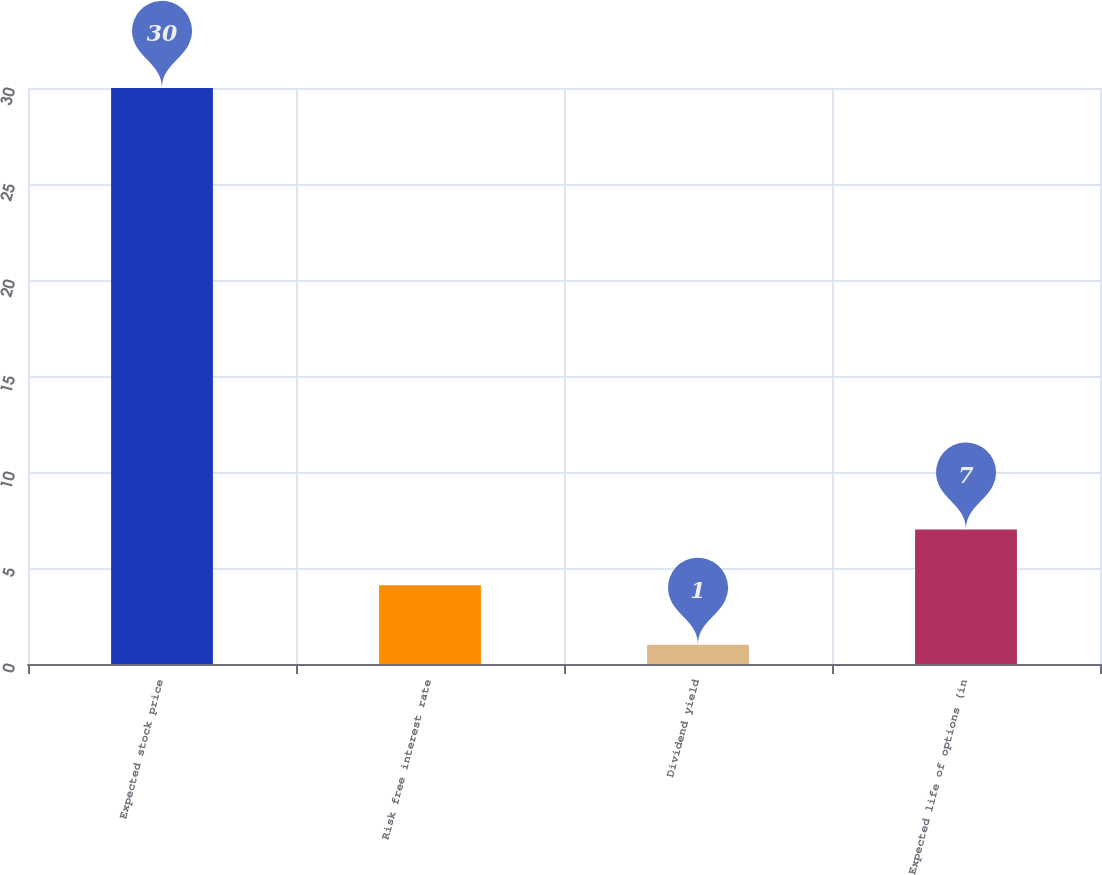<chart> <loc_0><loc_0><loc_500><loc_500><bar_chart><fcel>Expected stock price<fcel>Risk free interest rate<fcel>Dividend yield<fcel>Expected life of options (in<nl><fcel>30<fcel>4.1<fcel>1<fcel>7<nl></chart> 